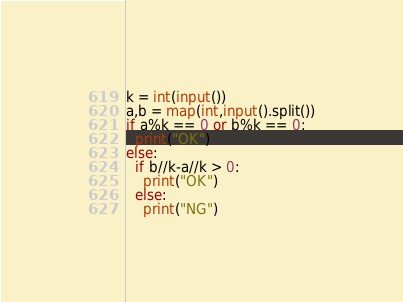<code> <loc_0><loc_0><loc_500><loc_500><_Python_>k = int(input())
a,b = map(int,input().split())
if a%k == 0 or b%k == 0:
  print("OK")
else:
  if b//k-a//k > 0:
    print("OK")
  else:
    print("NG")</code> 